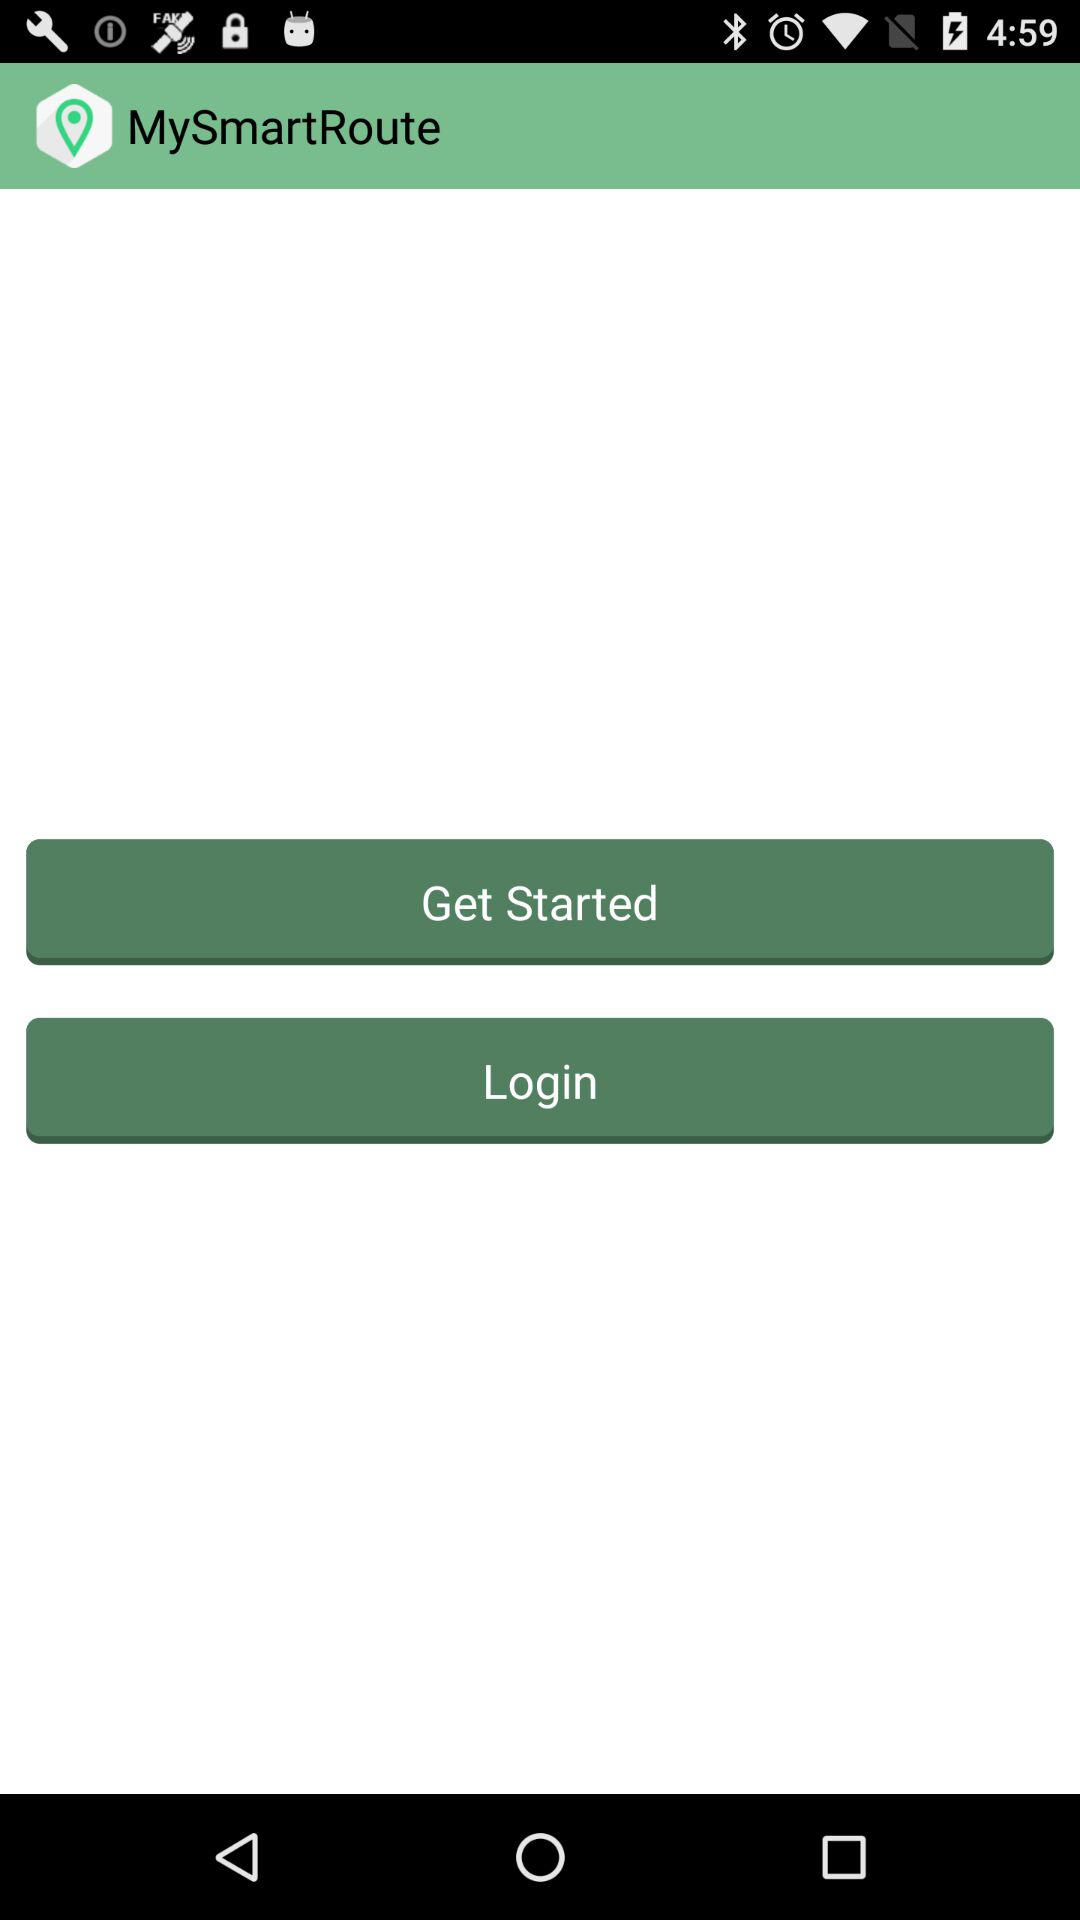What is the app name? The app name is "MySmartRoute". 